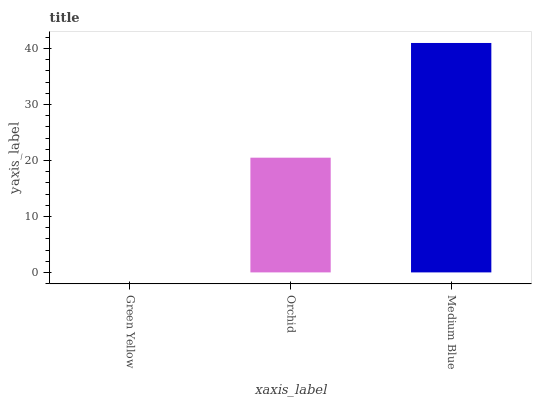Is Green Yellow the minimum?
Answer yes or no. Yes. Is Medium Blue the maximum?
Answer yes or no. Yes. Is Orchid the minimum?
Answer yes or no. No. Is Orchid the maximum?
Answer yes or no. No. Is Orchid greater than Green Yellow?
Answer yes or no. Yes. Is Green Yellow less than Orchid?
Answer yes or no. Yes. Is Green Yellow greater than Orchid?
Answer yes or no. No. Is Orchid less than Green Yellow?
Answer yes or no. No. Is Orchid the high median?
Answer yes or no. Yes. Is Orchid the low median?
Answer yes or no. Yes. Is Green Yellow the high median?
Answer yes or no. No. Is Green Yellow the low median?
Answer yes or no. No. 